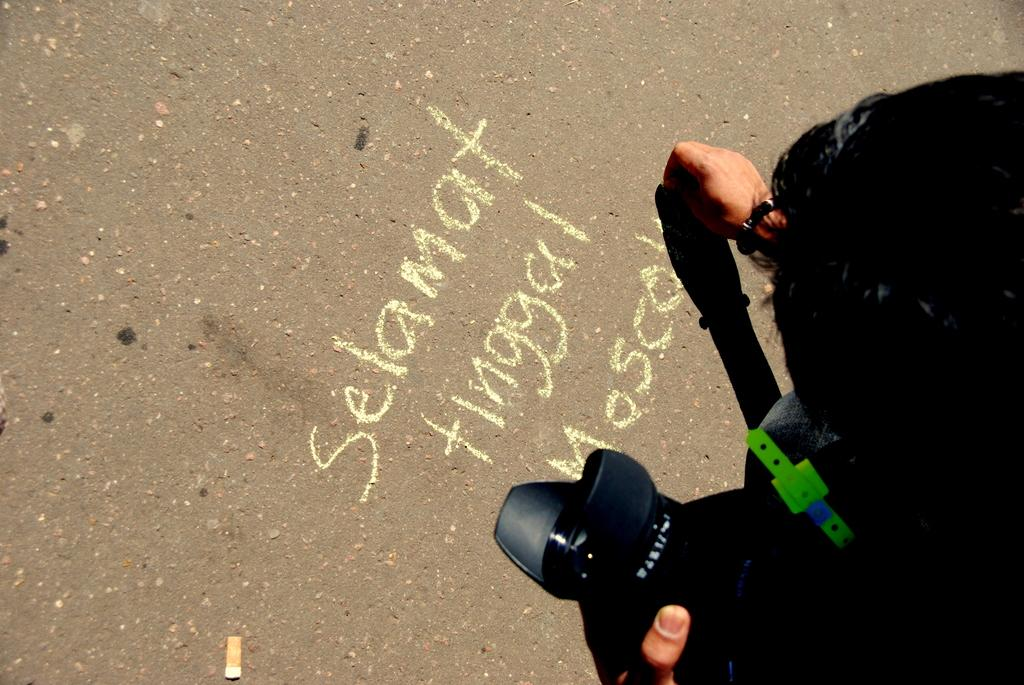What is the main subject of the image? There is a person in the image. Where is the person located in the image? The person is present over a place. What is the person holding in their hand? The person is holding a camera in their hand. What activity is the person engaged in? The person is writing something on the ground with a chalk piece. What type of fruit is the person holding in their other hand in the image? There is no fruit present in the image; the person is holding a camera in their hand. What part of the person's body is missing in the image? There is no indication that any part of the person's body is missing in the image. 